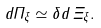Convert formula to latex. <formula><loc_0><loc_0><loc_500><loc_500>d \Pi _ { \xi } \simeq \delta d \, \Xi _ { \xi } .</formula> 